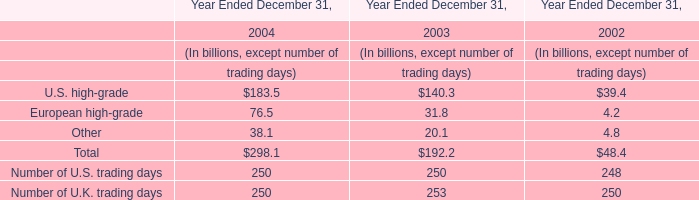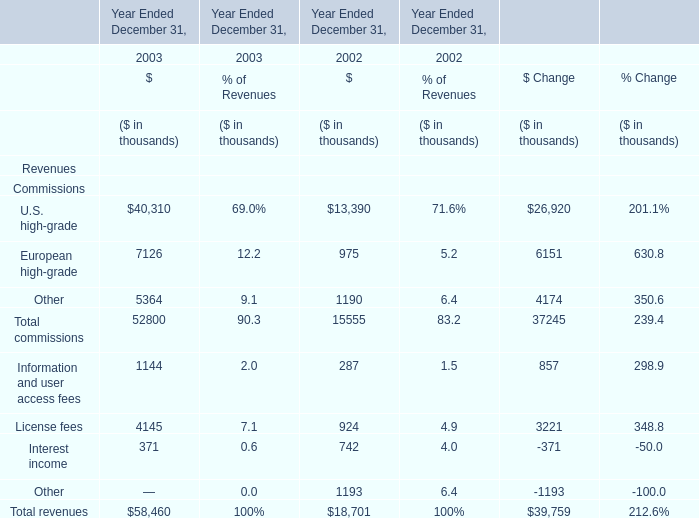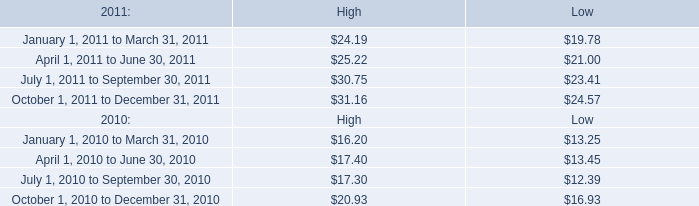What is the growing rate of European high-grade in the year with the most U.S. high-grade? 
Computations: ((7126 - 975) / 7126)
Answer: 0.86318. 